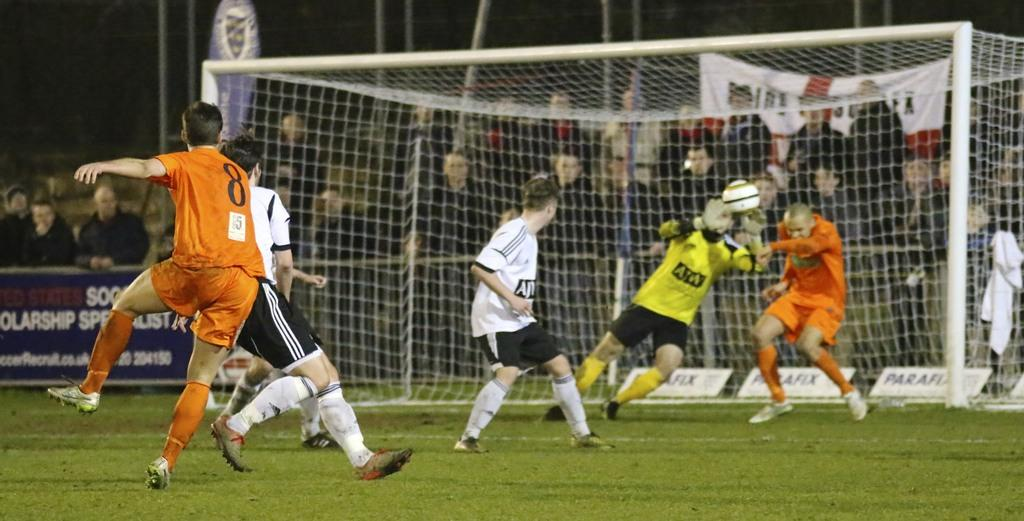<image>
Create a compact narrative representing the image presented. A soccer player wearing number 8 on the orange team shoots the ball. 